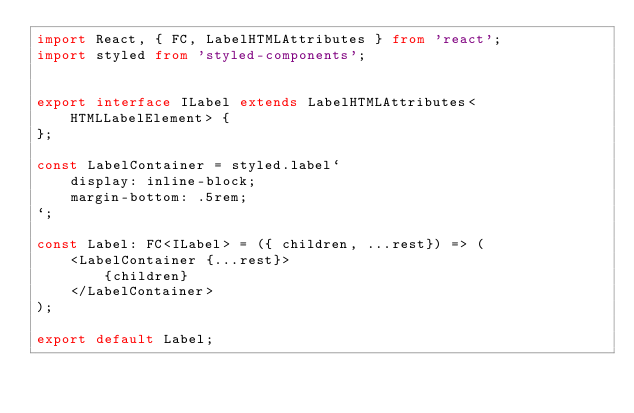Convert code to text. <code><loc_0><loc_0><loc_500><loc_500><_TypeScript_>import React, { FC, LabelHTMLAttributes } from 'react';
import styled from 'styled-components';


export interface ILabel extends LabelHTMLAttributes<HTMLLabelElement> {
};

const LabelContainer = styled.label`
    display: inline-block;
    margin-bottom: .5rem;
`;

const Label: FC<ILabel> = ({ children, ...rest}) => (
    <LabelContainer {...rest}>
        {children}
    </LabelContainer>
);

export default Label;</code> 